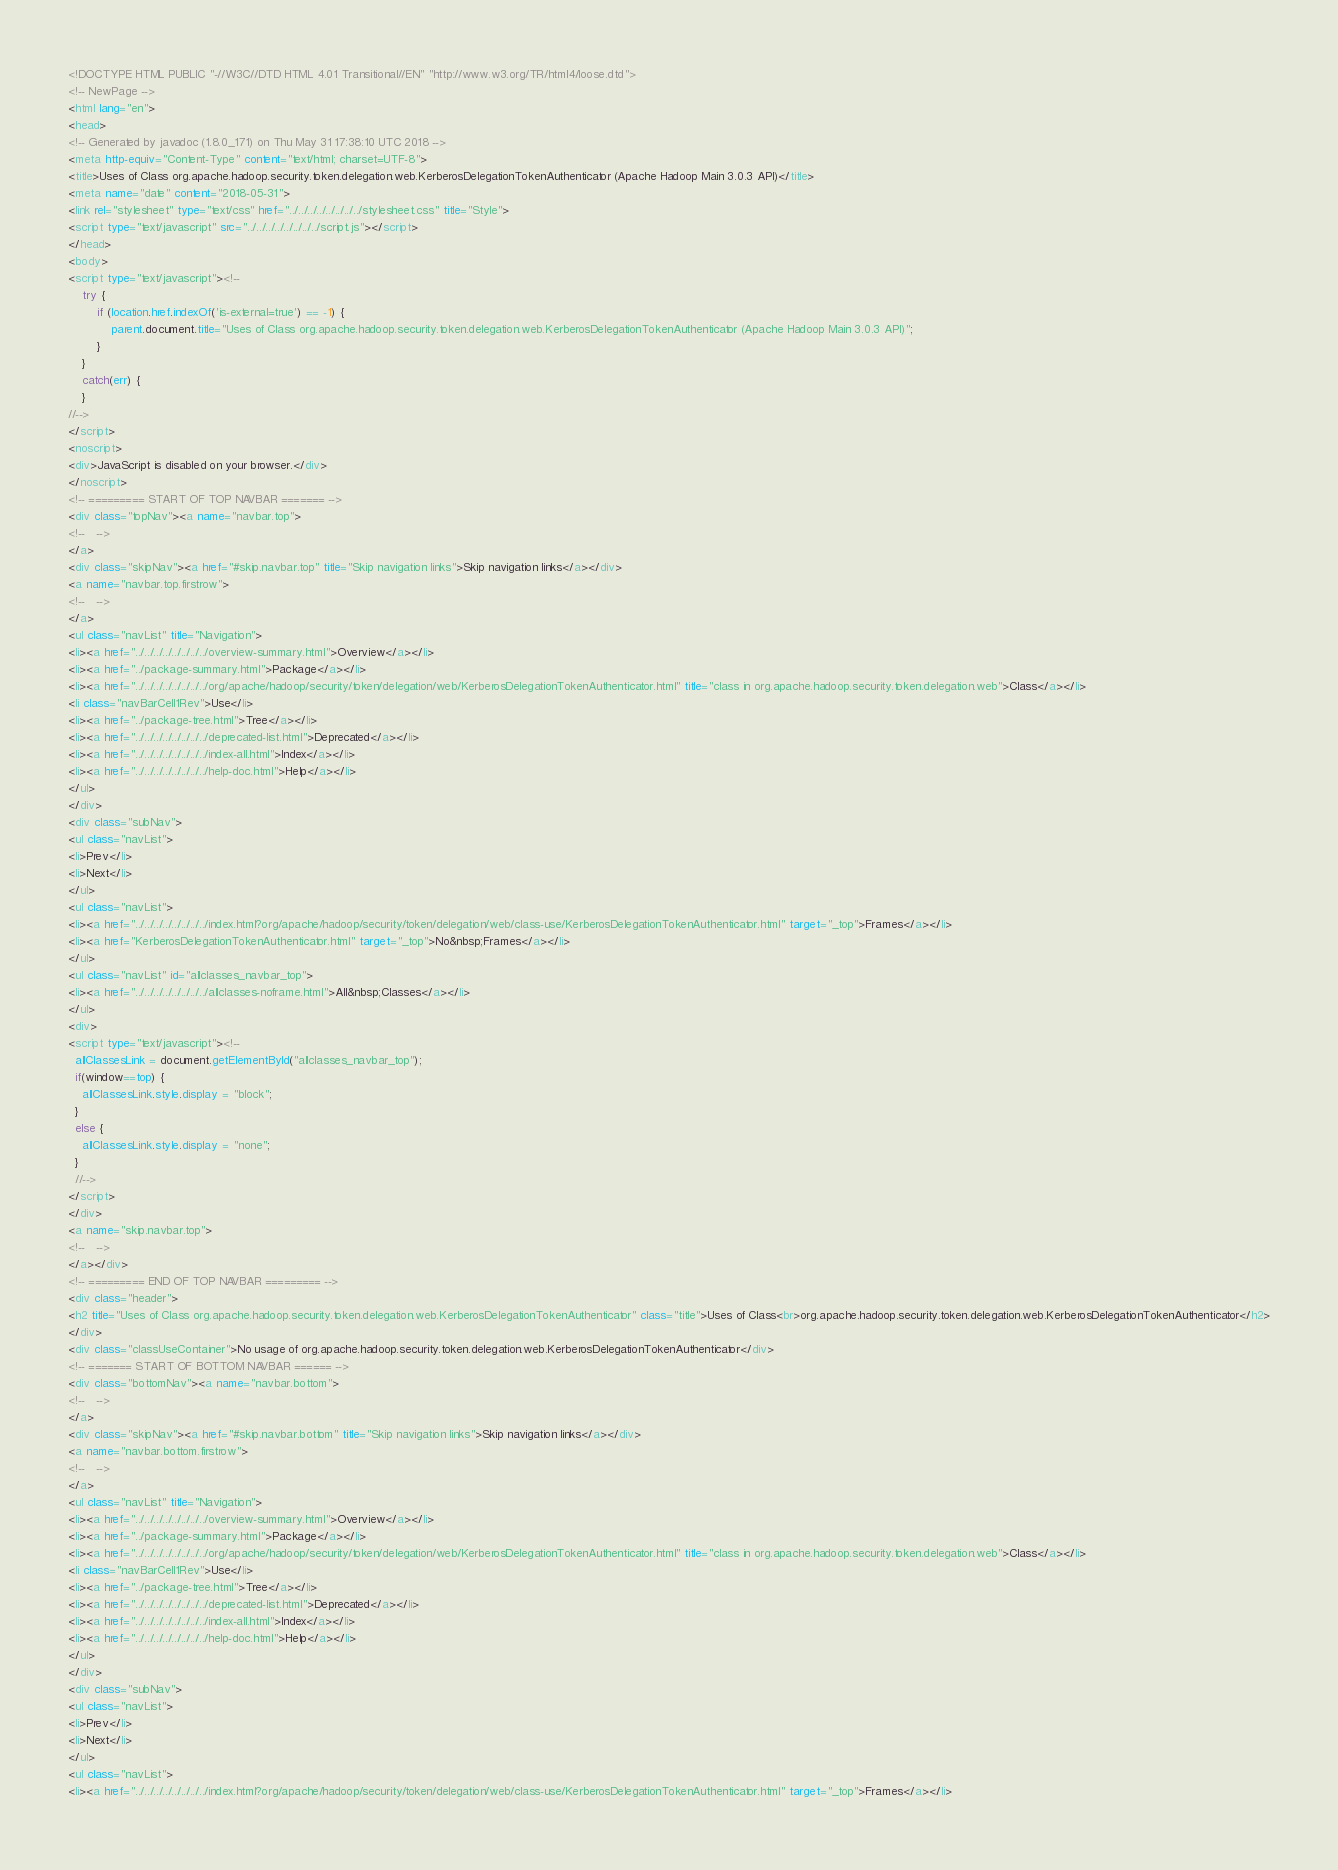Convert code to text. <code><loc_0><loc_0><loc_500><loc_500><_HTML_><!DOCTYPE HTML PUBLIC "-//W3C//DTD HTML 4.01 Transitional//EN" "http://www.w3.org/TR/html4/loose.dtd">
<!-- NewPage -->
<html lang="en">
<head>
<!-- Generated by javadoc (1.8.0_171) on Thu May 31 17:38:10 UTC 2018 -->
<meta http-equiv="Content-Type" content="text/html; charset=UTF-8">
<title>Uses of Class org.apache.hadoop.security.token.delegation.web.KerberosDelegationTokenAuthenticator (Apache Hadoop Main 3.0.3 API)</title>
<meta name="date" content="2018-05-31">
<link rel="stylesheet" type="text/css" href="../../../../../../../../stylesheet.css" title="Style">
<script type="text/javascript" src="../../../../../../../../script.js"></script>
</head>
<body>
<script type="text/javascript"><!--
    try {
        if (location.href.indexOf('is-external=true') == -1) {
            parent.document.title="Uses of Class org.apache.hadoop.security.token.delegation.web.KerberosDelegationTokenAuthenticator (Apache Hadoop Main 3.0.3 API)";
        }
    }
    catch(err) {
    }
//-->
</script>
<noscript>
<div>JavaScript is disabled on your browser.</div>
</noscript>
<!-- ========= START OF TOP NAVBAR ======= -->
<div class="topNav"><a name="navbar.top">
<!--   -->
</a>
<div class="skipNav"><a href="#skip.navbar.top" title="Skip navigation links">Skip navigation links</a></div>
<a name="navbar.top.firstrow">
<!--   -->
</a>
<ul class="navList" title="Navigation">
<li><a href="../../../../../../../../overview-summary.html">Overview</a></li>
<li><a href="../package-summary.html">Package</a></li>
<li><a href="../../../../../../../../org/apache/hadoop/security/token/delegation/web/KerberosDelegationTokenAuthenticator.html" title="class in org.apache.hadoop.security.token.delegation.web">Class</a></li>
<li class="navBarCell1Rev">Use</li>
<li><a href="../package-tree.html">Tree</a></li>
<li><a href="../../../../../../../../deprecated-list.html">Deprecated</a></li>
<li><a href="../../../../../../../../index-all.html">Index</a></li>
<li><a href="../../../../../../../../help-doc.html">Help</a></li>
</ul>
</div>
<div class="subNav">
<ul class="navList">
<li>Prev</li>
<li>Next</li>
</ul>
<ul class="navList">
<li><a href="../../../../../../../../index.html?org/apache/hadoop/security/token/delegation/web/class-use/KerberosDelegationTokenAuthenticator.html" target="_top">Frames</a></li>
<li><a href="KerberosDelegationTokenAuthenticator.html" target="_top">No&nbsp;Frames</a></li>
</ul>
<ul class="navList" id="allclasses_navbar_top">
<li><a href="../../../../../../../../allclasses-noframe.html">All&nbsp;Classes</a></li>
</ul>
<div>
<script type="text/javascript"><!--
  allClassesLink = document.getElementById("allclasses_navbar_top");
  if(window==top) {
    allClassesLink.style.display = "block";
  }
  else {
    allClassesLink.style.display = "none";
  }
  //-->
</script>
</div>
<a name="skip.navbar.top">
<!--   -->
</a></div>
<!-- ========= END OF TOP NAVBAR ========= -->
<div class="header">
<h2 title="Uses of Class org.apache.hadoop.security.token.delegation.web.KerberosDelegationTokenAuthenticator" class="title">Uses of Class<br>org.apache.hadoop.security.token.delegation.web.KerberosDelegationTokenAuthenticator</h2>
</div>
<div class="classUseContainer">No usage of org.apache.hadoop.security.token.delegation.web.KerberosDelegationTokenAuthenticator</div>
<!-- ======= START OF BOTTOM NAVBAR ====== -->
<div class="bottomNav"><a name="navbar.bottom">
<!--   -->
</a>
<div class="skipNav"><a href="#skip.navbar.bottom" title="Skip navigation links">Skip navigation links</a></div>
<a name="navbar.bottom.firstrow">
<!--   -->
</a>
<ul class="navList" title="Navigation">
<li><a href="../../../../../../../../overview-summary.html">Overview</a></li>
<li><a href="../package-summary.html">Package</a></li>
<li><a href="../../../../../../../../org/apache/hadoop/security/token/delegation/web/KerberosDelegationTokenAuthenticator.html" title="class in org.apache.hadoop.security.token.delegation.web">Class</a></li>
<li class="navBarCell1Rev">Use</li>
<li><a href="../package-tree.html">Tree</a></li>
<li><a href="../../../../../../../../deprecated-list.html">Deprecated</a></li>
<li><a href="../../../../../../../../index-all.html">Index</a></li>
<li><a href="../../../../../../../../help-doc.html">Help</a></li>
</ul>
</div>
<div class="subNav">
<ul class="navList">
<li>Prev</li>
<li>Next</li>
</ul>
<ul class="navList">
<li><a href="../../../../../../../../index.html?org/apache/hadoop/security/token/delegation/web/class-use/KerberosDelegationTokenAuthenticator.html" target="_top">Frames</a></li></code> 